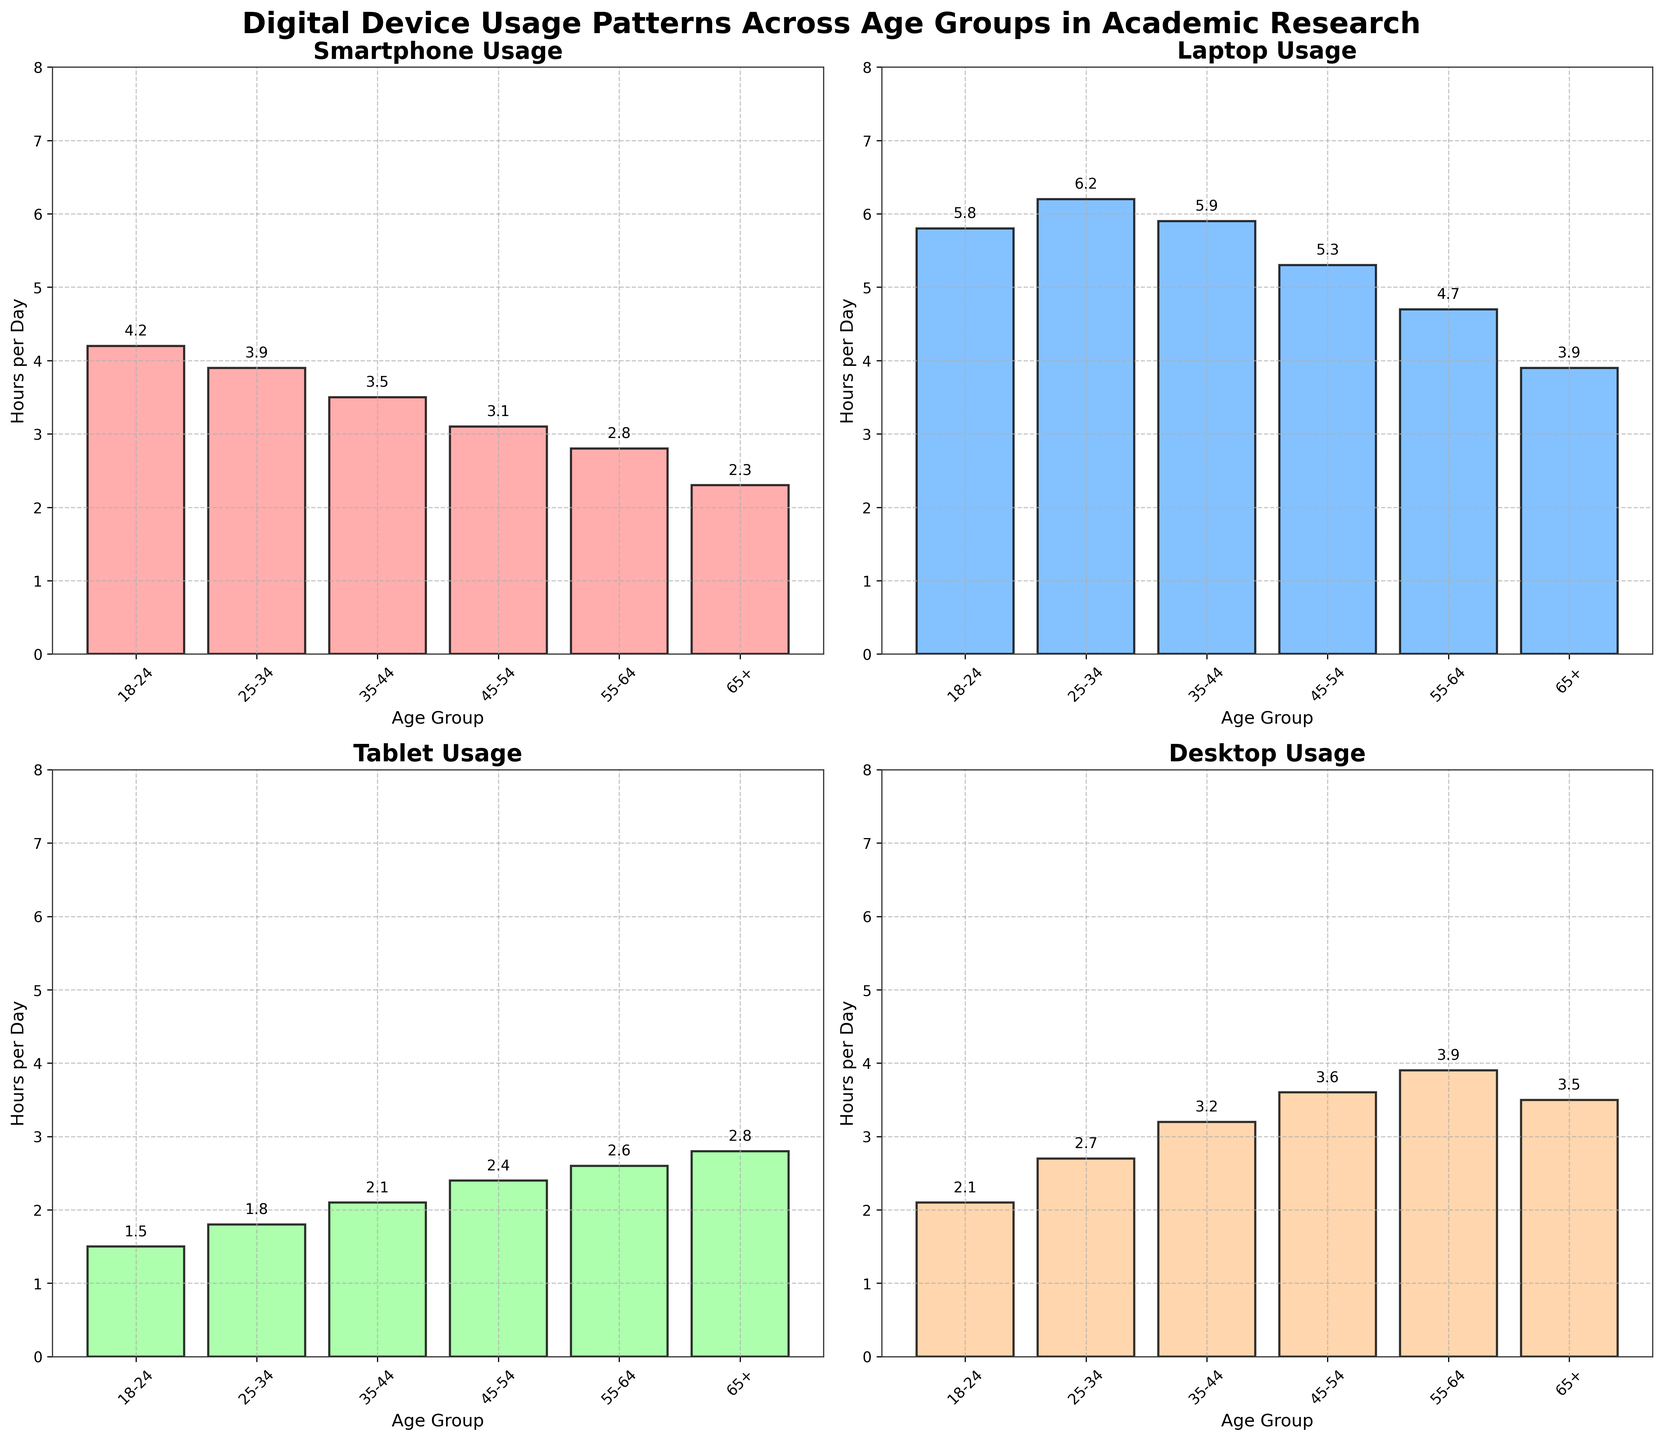Which age group spends the most hours per day on a laptop? Identify the bar for each age group under the device label "Laptop" and compare the heights. The group 25-34 has the tallest bar at 6.2 hours per day.
Answer: 25-34 What is the average usage time of a desktop across all age groups? Add up the hours per day for each age group for the desktop and divide by the number of age groups: (2.1 + 2.7 + 3.2 + 3.6 + 3.9 + 3.5) / 6 = 3.17 hours per day.
Answer: 3.17 Which device has the least usage among the 18-24 age group? Look at the heights of the bars for the 18-24 age group across all subplots. The "Tablet" has the shortest bar at 1.5 hours per day.
Answer: Tablet How many hours per day does the 55-64 age group use a smartphone compared to a tablet? Find the bars for the 55-64 age group under "Smartphone" and "Tablet" subplots. Smartphone usage is 2.8 hours per day and Tablet usage is 2.6 hours per day, so the difference is 2.8 - 2.6 = 0.2 hours.
Answer: 0.2 hours What is the title of the combined figure? The title displayed at the top is “Digital Device Usage Patterns Across Age Groups in Academic Research”.
Answer: Digital Device Usage Patterns Across Age Groups in Academic Research Which age group has the most balanced usage across all devices? Compare the bars within each age group across all subplots. The 65+ age group appears to have more consistent bar heights across all devices (Smartphone 2.3, Laptop 3.9, Tablet 2.8, Desktop 3.5).
Answer: 65+ What is the difference in laptop usage per day between the age groups 25-34 and 45-54? Find the laptop usage bars for age groups 25-34 and 45-54. 25-34 group uses it for 6.2 hours, and the 45-54 group for 5.3 hours, so the difference is 6.2 - 5.3 = 0.9 hours per day.
Answer: 0.9 hours Which device is used the least amount of time by the 35-44 age group? Compare the heights of the bars for the 35-44 age group across all subplots. The "Smartphone" has the shortest bar at 3.5 hours per day.
Answer: Smartphone 